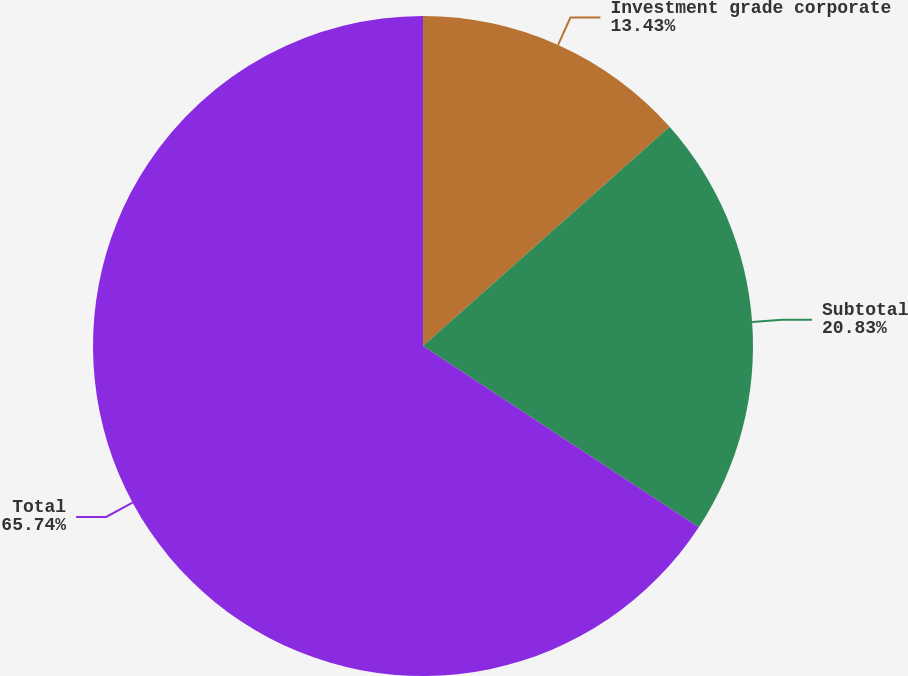<chart> <loc_0><loc_0><loc_500><loc_500><pie_chart><fcel>Investment grade corporate<fcel>Subtotal<fcel>Total<nl><fcel>13.43%<fcel>20.83%<fcel>65.75%<nl></chart> 